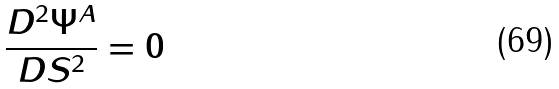<formula> <loc_0><loc_0><loc_500><loc_500>\frac { D ^ { 2 } \Psi ^ { A } } { D S ^ { 2 } } = 0</formula> 